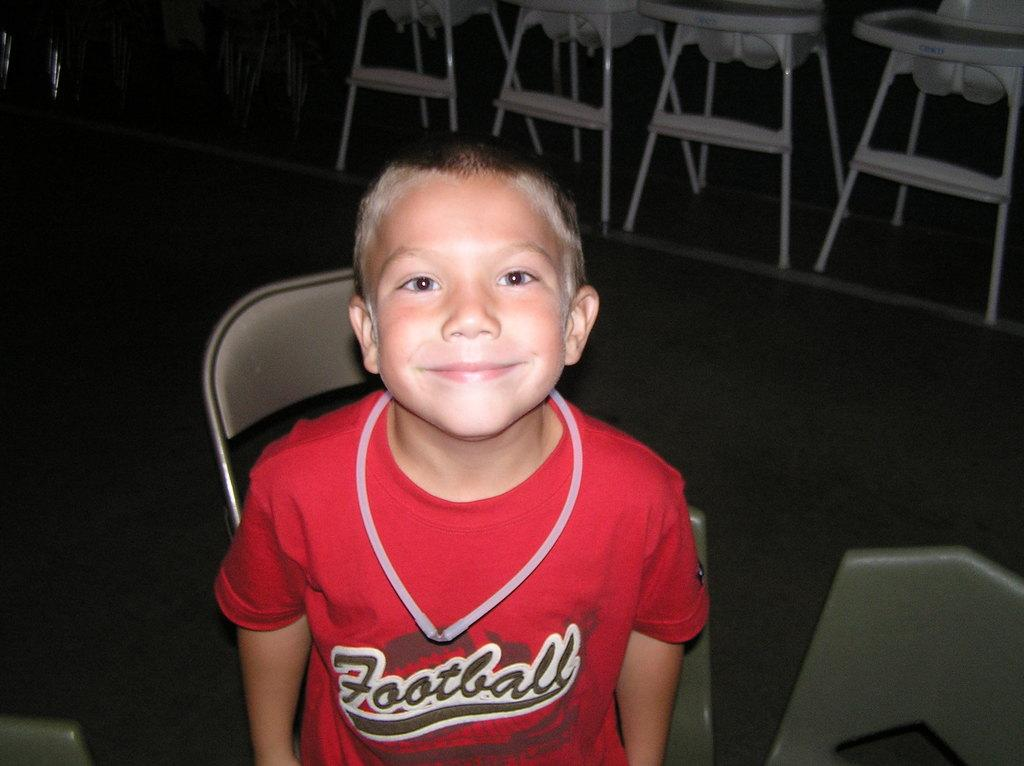Provide a one-sentence caption for the provided image. A smiling little boys who clearly likes football. 